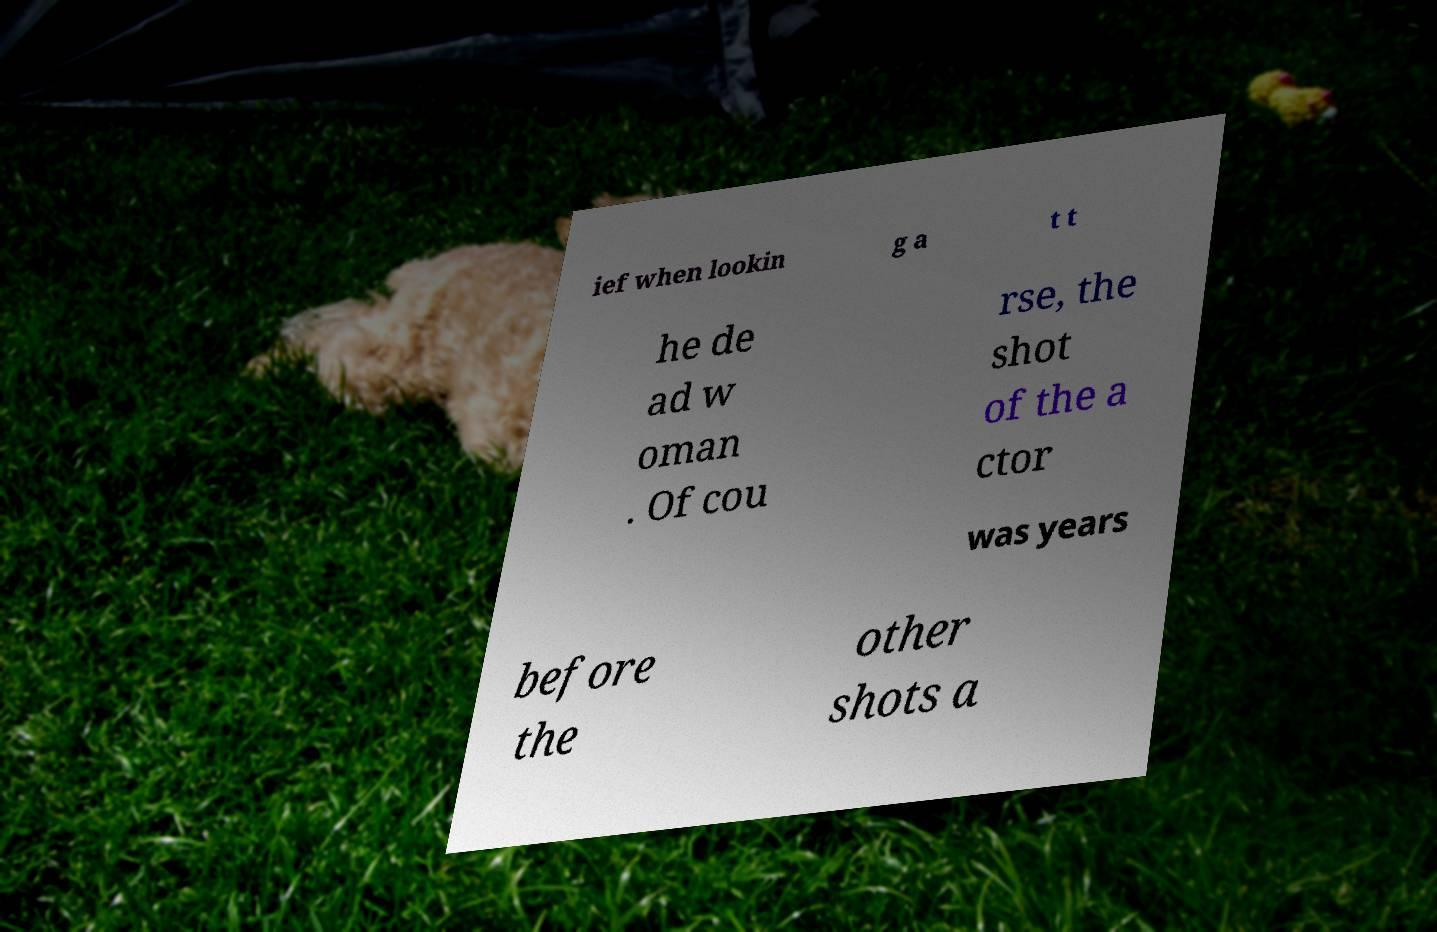What messages or text are displayed in this image? I need them in a readable, typed format. ief when lookin g a t t he de ad w oman . Of cou rse, the shot of the a ctor was years before the other shots a 